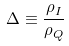Convert formula to latex. <formula><loc_0><loc_0><loc_500><loc_500>\Delta \equiv \frac { \rho _ { I } } { \rho _ { Q } }</formula> 